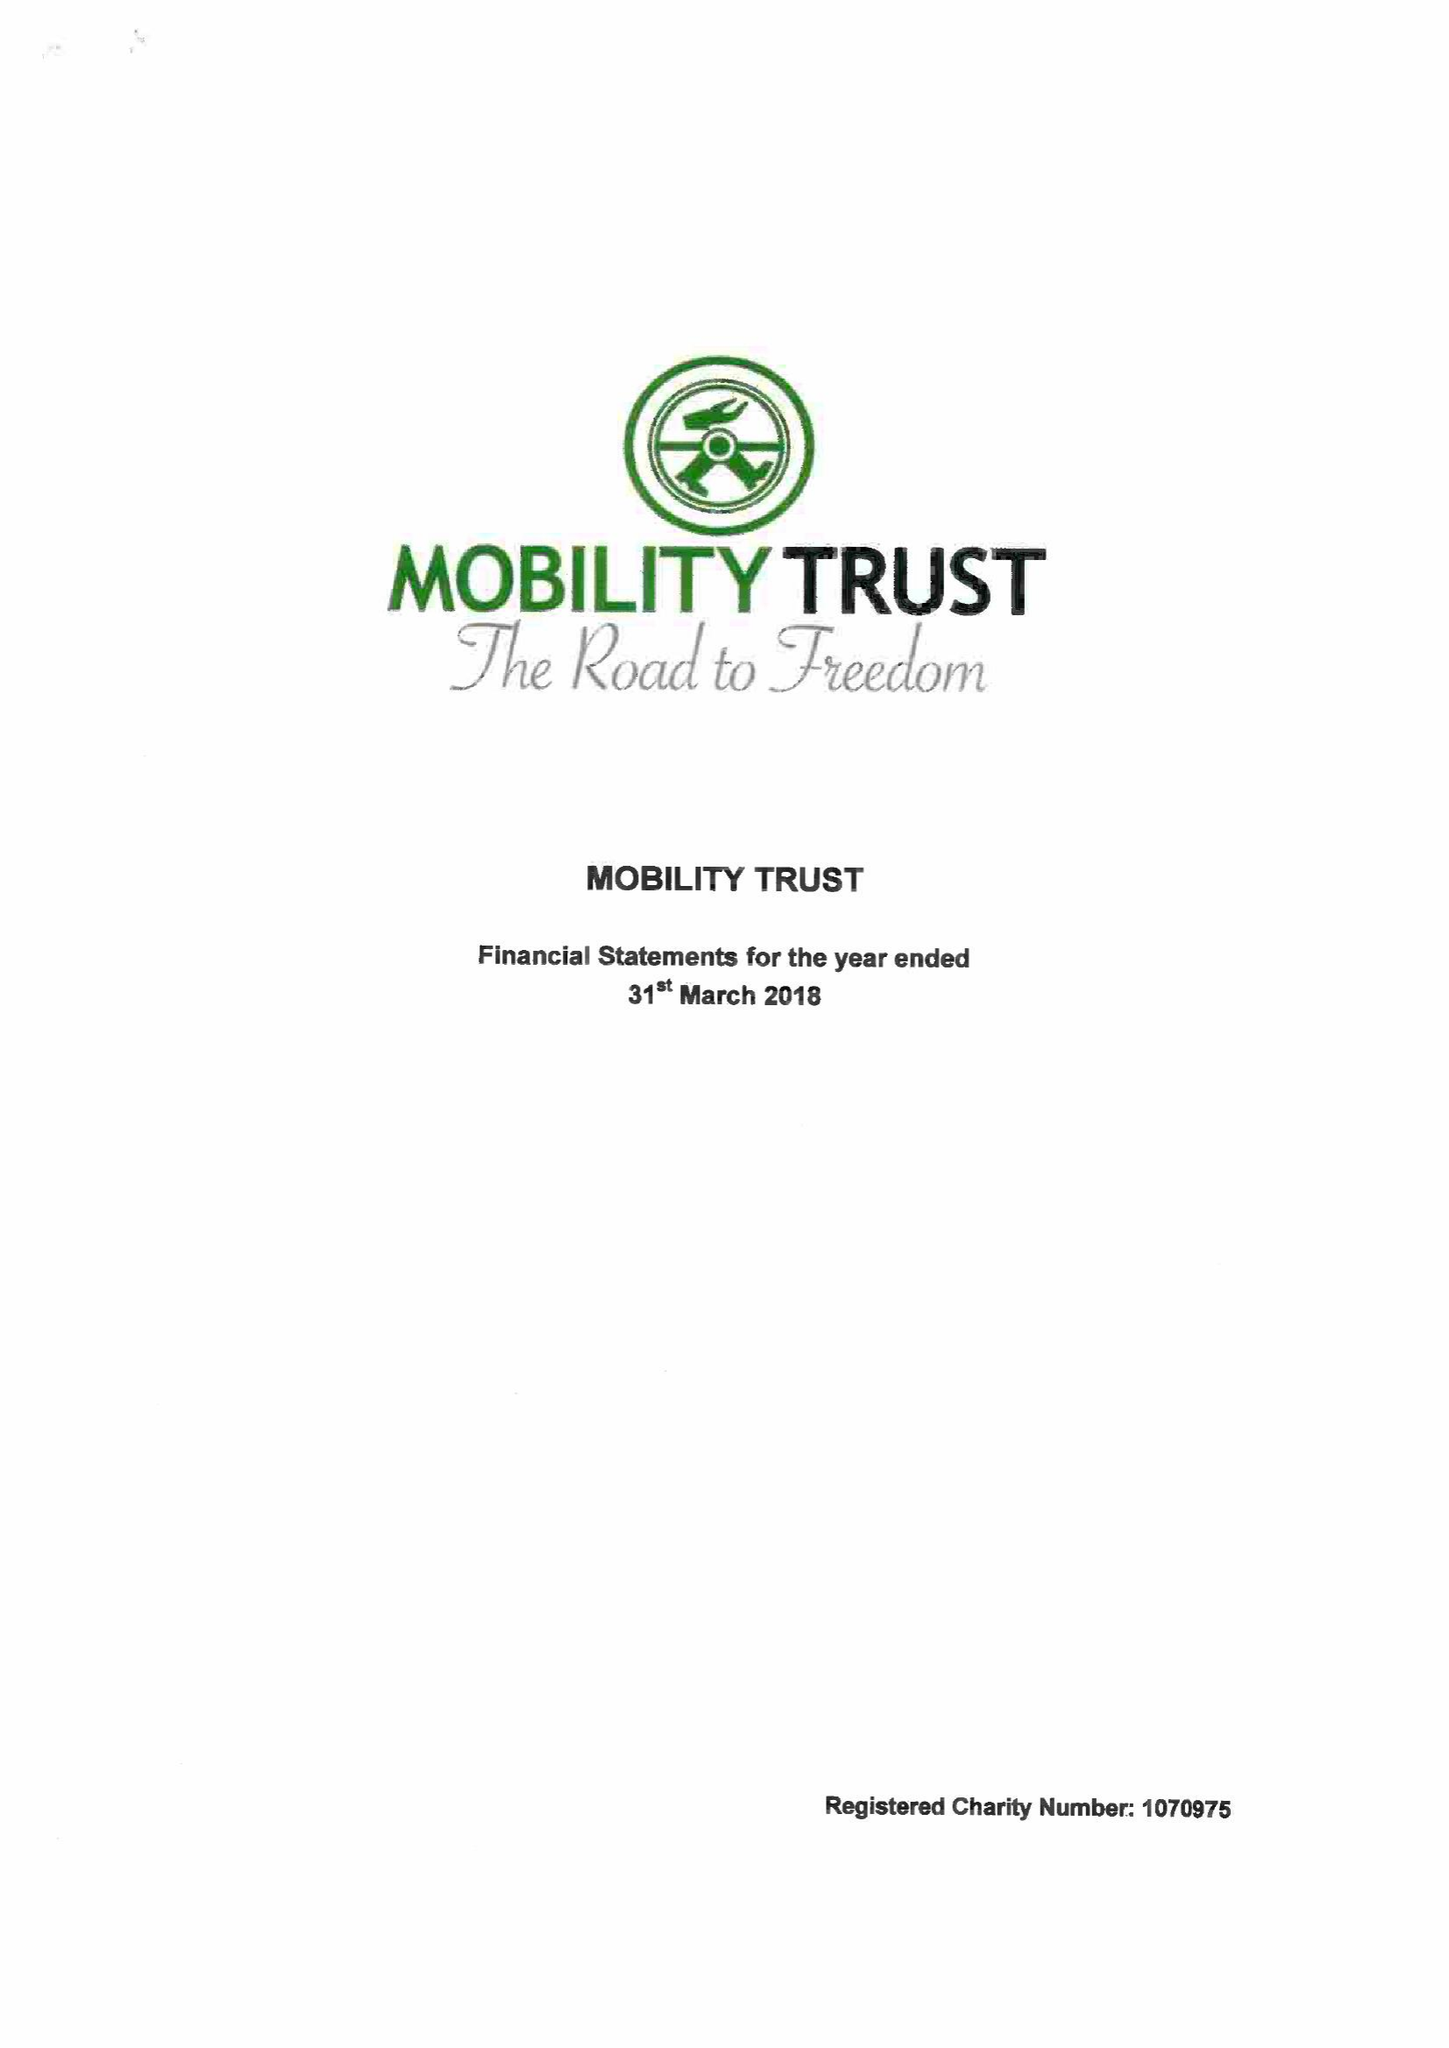What is the value for the income_annually_in_british_pounds?
Answer the question using a single word or phrase. 387794.00 